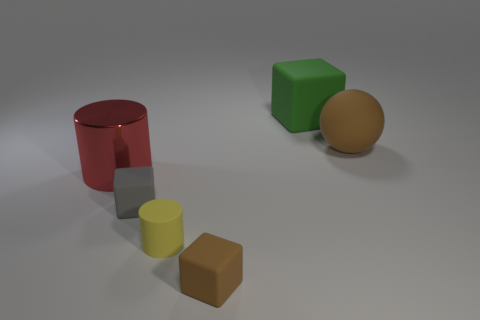Is there anything else that has the same material as the large red cylinder?
Your response must be concise. No. There is a thing that is the same color as the big ball; what is its size?
Provide a succinct answer. Small. There is a object that is the same color as the big sphere; what is its shape?
Ensure brevity in your answer.  Cube. Do the sphere and the red metal cylinder behind the tiny rubber cylinder have the same size?
Give a very brief answer. Yes. There is a object that is left of the small gray matte thing; is there a object that is behind it?
Your answer should be very brief. Yes. Is there a gray rubber thing that has the same shape as the red thing?
Offer a terse response. No. What number of big cylinders are in front of the tiny cube that is left of the small rubber block right of the gray thing?
Offer a terse response. 0. There is a tiny matte cylinder; does it have the same color as the rubber block that is behind the red metal cylinder?
Offer a terse response. No. How many objects are either big cylinders that are on the left side of the gray block or tiny objects that are right of the yellow rubber thing?
Provide a succinct answer. 2. Are there more green blocks in front of the tiny yellow rubber object than small matte cubes that are behind the big green rubber object?
Offer a terse response. No. 